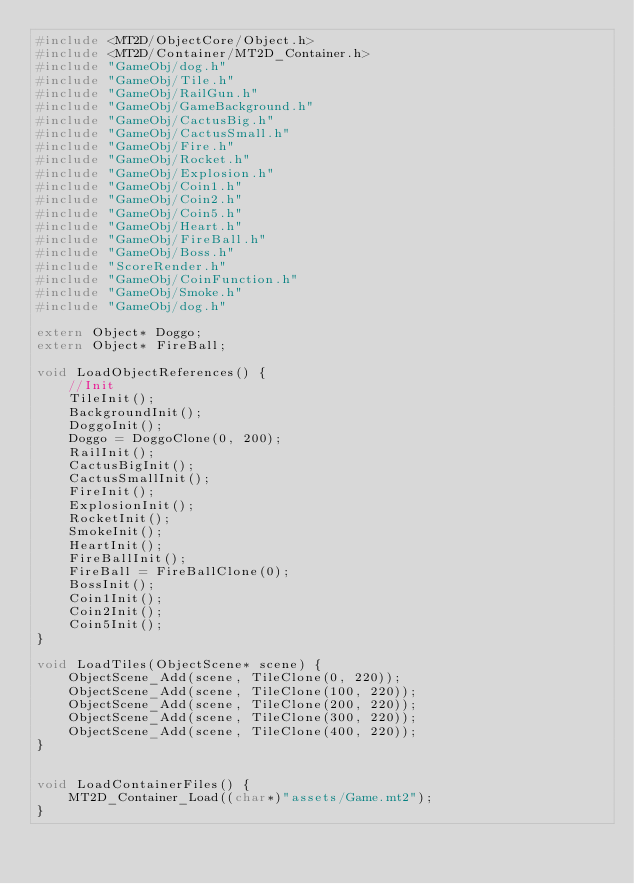Convert code to text. <code><loc_0><loc_0><loc_500><loc_500><_C++_>#include <MT2D/ObjectCore/Object.h>
#include <MT2D/Container/MT2D_Container.h>
#include "GameObj/dog.h"
#include "GameObj/Tile.h"
#include "GameObj/RailGun.h"
#include "GameObj/GameBackground.h"
#include "GameObj/CactusBig.h"
#include "GameObj/CactusSmall.h"
#include "GameObj/Fire.h"
#include "GameObj/Rocket.h"
#include "GameObj/Explosion.h"
#include "GameObj/Coin1.h"
#include "GameObj/Coin2.h"
#include "GameObj/Coin5.h"
#include "GameObj/Heart.h"
#include "GameObj/FireBall.h"
#include "GameObj/Boss.h"
#include "ScoreRender.h"
#include "GameObj/CoinFunction.h"
#include "GameObj/Smoke.h"
#include "GameObj/dog.h"

extern Object* Doggo;
extern Object* FireBall;

void LoadObjectReferences() {
	//Init
	TileInit();
	BackgroundInit();
	DoggoInit();
	Doggo = DoggoClone(0, 200);
	RailInit();
	CactusBigInit();
	CactusSmallInit();
	FireInit();
	ExplosionInit();
	RocketInit();
	SmokeInit();
	HeartInit();
	FireBallInit();
	FireBall = FireBallClone(0);
	BossInit();
	Coin1Init();
	Coin2Init();
	Coin5Init();
}

void LoadTiles(ObjectScene* scene) {
	ObjectScene_Add(scene, TileClone(0, 220));
	ObjectScene_Add(scene, TileClone(100, 220));
	ObjectScene_Add(scene, TileClone(200, 220));
	ObjectScene_Add(scene, TileClone(300, 220));
	ObjectScene_Add(scene, TileClone(400, 220));
}


void LoadContainerFiles() {
	MT2D_Container_Load((char*)"assets/Game.mt2");
}</code> 